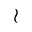Convert formula to latex. <formula><loc_0><loc_0><loc_500><loc_500>\wr</formula> 